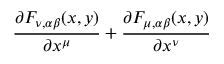Convert formula to latex. <formula><loc_0><loc_0><loc_500><loc_500>\frac { \partial F _ { \nu , \alpha \beta } ( x , y ) } { \partial x ^ { \mu } } + \frac { \partial F _ { \mu , \alpha \beta } ( x , y ) } { \partial x ^ { \nu } }</formula> 